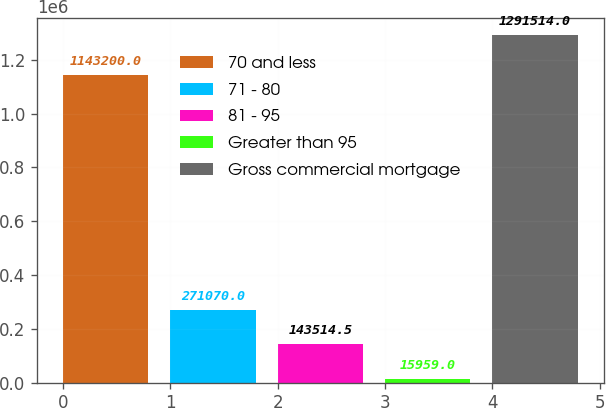<chart> <loc_0><loc_0><loc_500><loc_500><bar_chart><fcel>70 and less<fcel>71 - 80<fcel>81 - 95<fcel>Greater than 95<fcel>Gross commercial mortgage<nl><fcel>1.1432e+06<fcel>271070<fcel>143514<fcel>15959<fcel>1.29151e+06<nl></chart> 